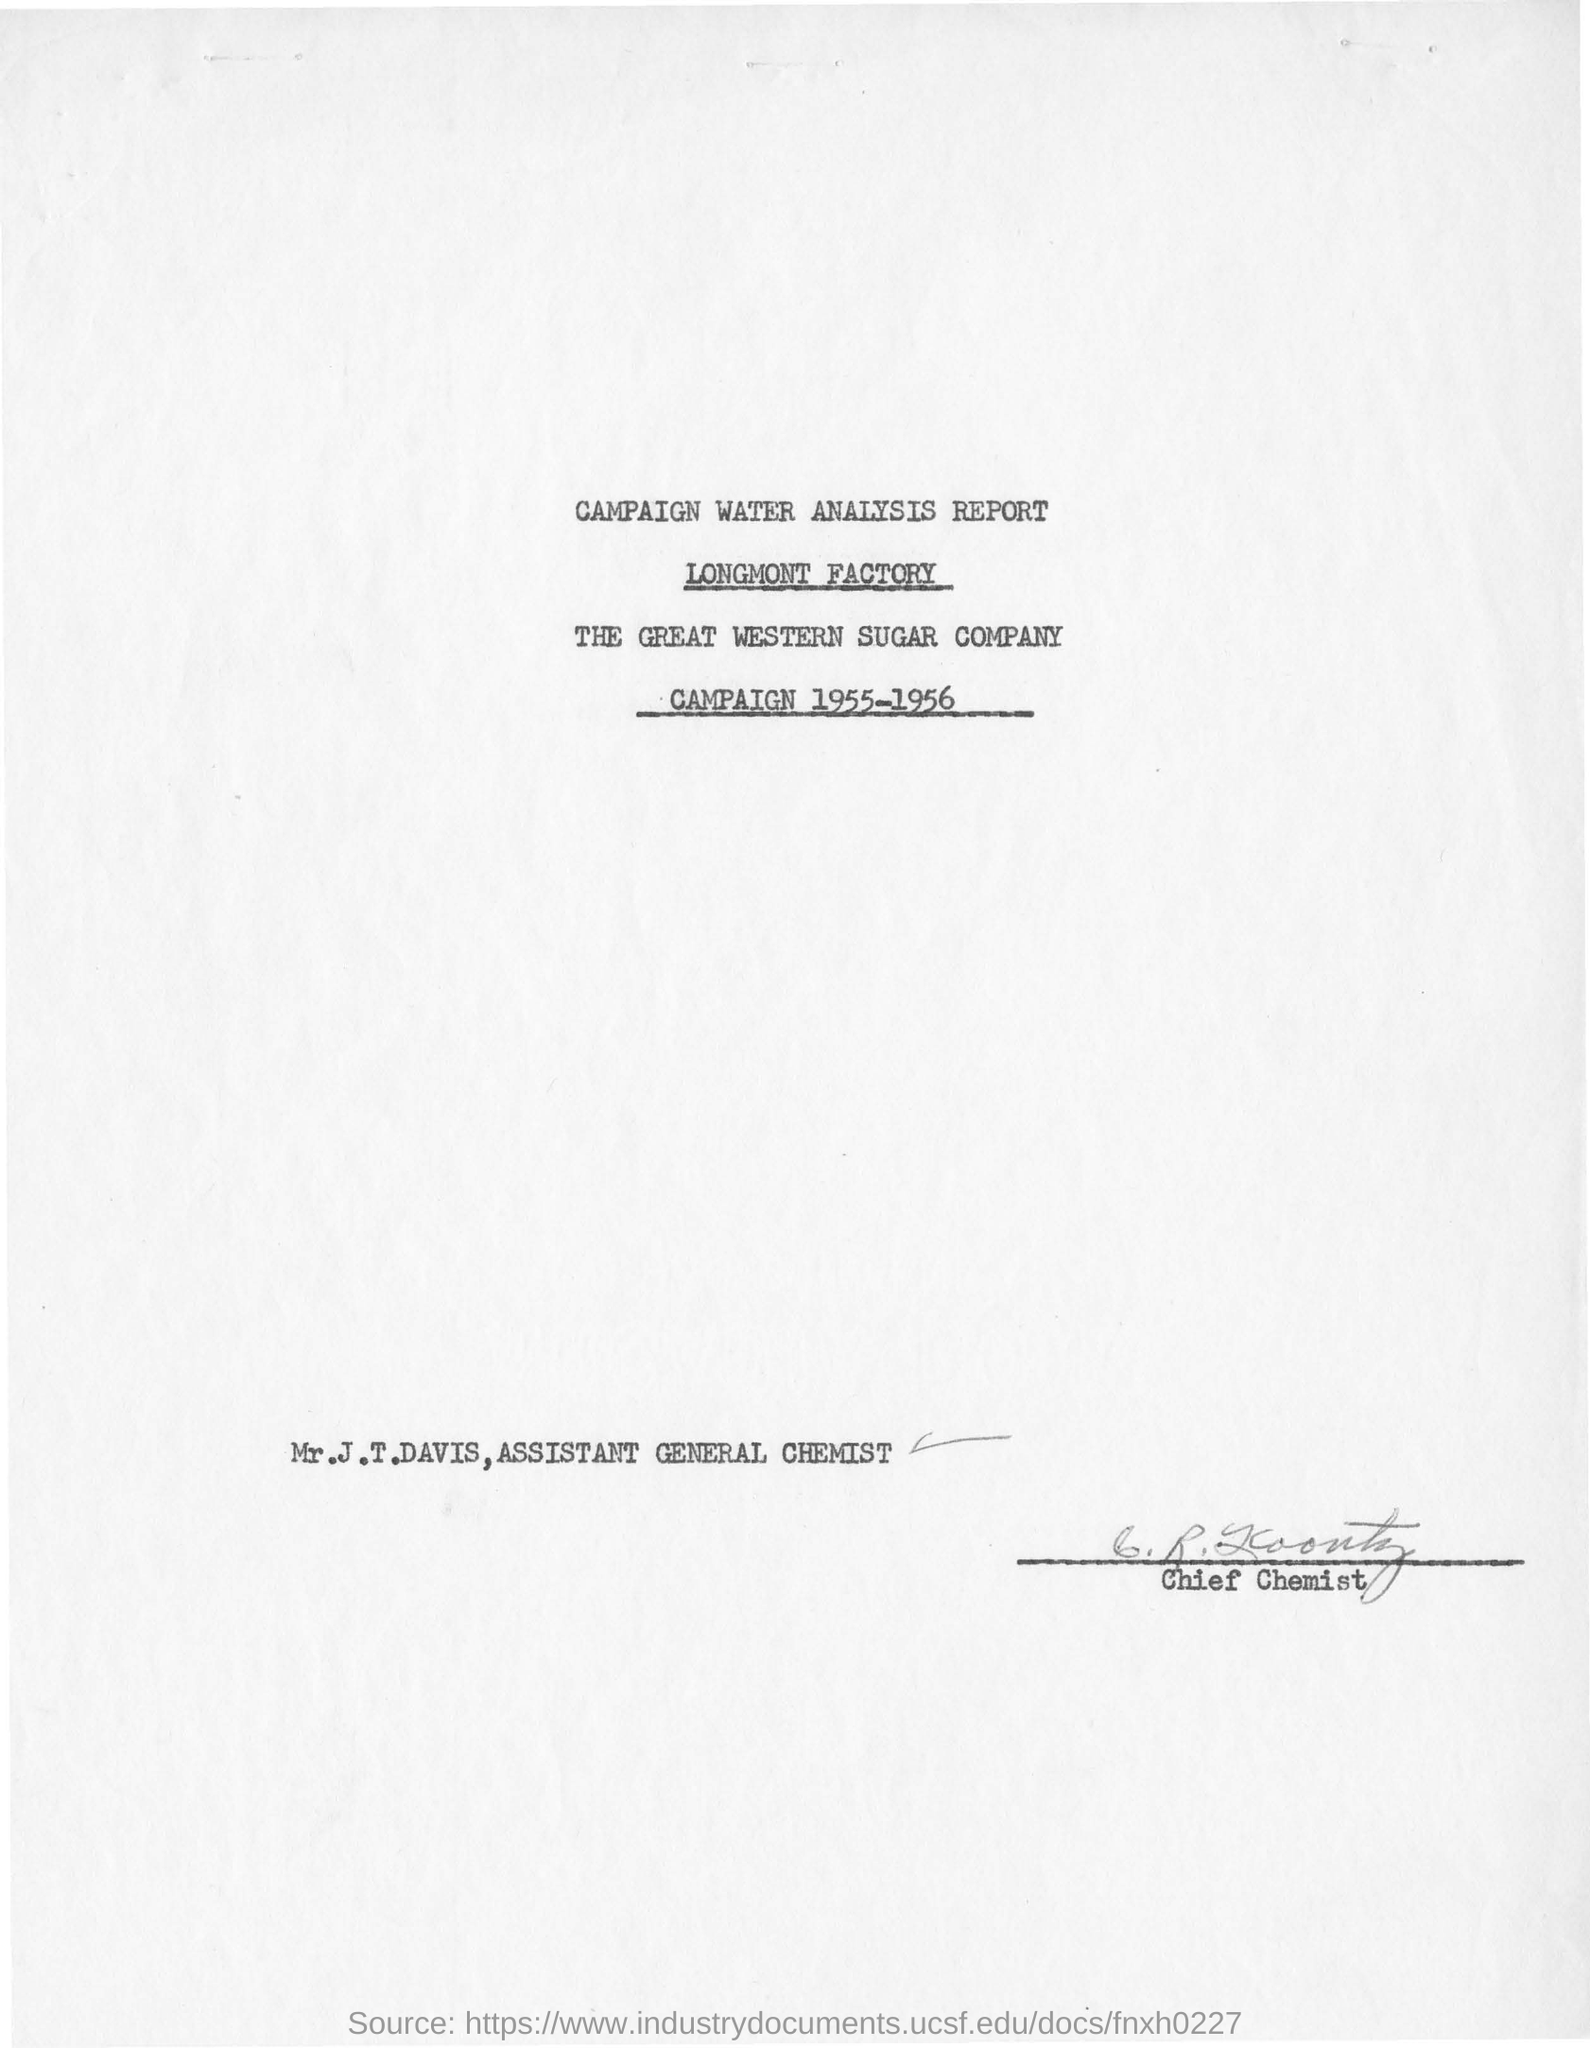What is the Title of the document ?
Give a very brief answer. Campaign water analysis report. What is the factory name ?
Your response must be concise. LONGMONT. What is the year mentioned in the document ?
Provide a short and direct response. 1955-1956. Who is Assistant General Chemist ?
Keep it short and to the point. Mr.J.T.DAVIS. 